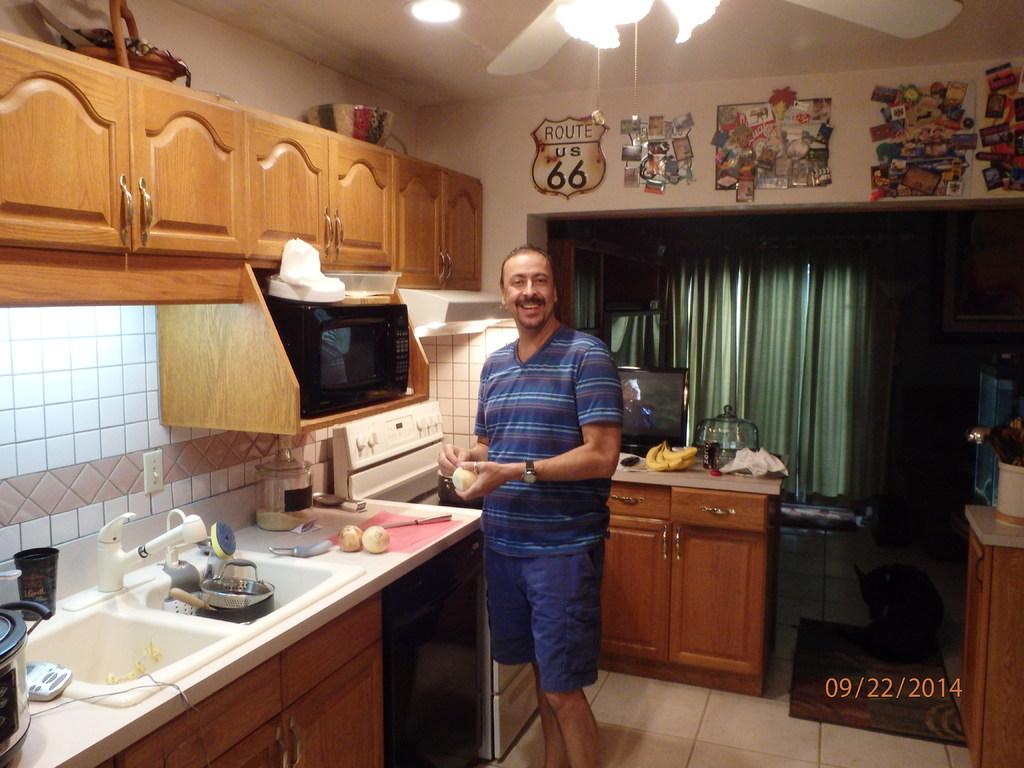What route number can you see on the sign above the man?
Keep it short and to the point. 66. What is the date stamp of this photo?
Your answer should be very brief. 09/22/2014. 